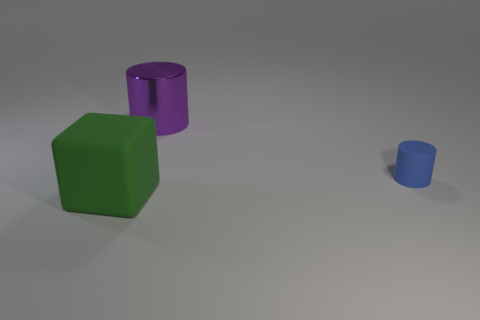Add 3 tiny blue rubber things. How many objects exist? 6 Add 2 large purple objects. How many large purple objects are left? 3 Add 1 shiny things. How many shiny things exist? 2 Subtract all purple cylinders. How many cylinders are left? 1 Subtract 0 brown blocks. How many objects are left? 3 Subtract all cylinders. How many objects are left? 1 Subtract 1 cubes. How many cubes are left? 0 Subtract all purple cylinders. Subtract all red spheres. How many cylinders are left? 1 Subtract all yellow blocks. How many blue cylinders are left? 1 Subtract all big metal things. Subtract all large things. How many objects are left? 0 